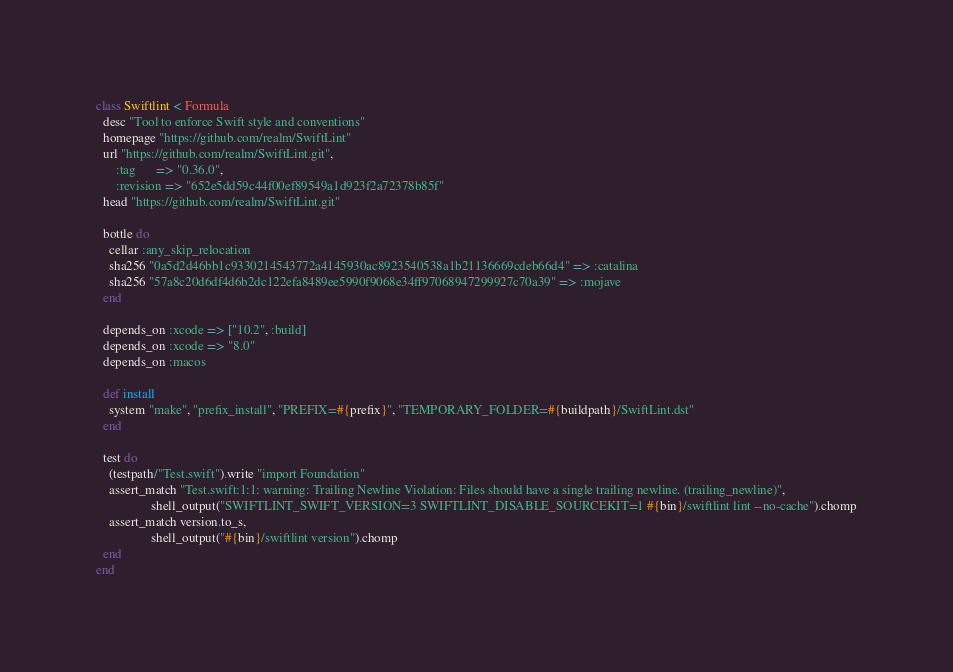<code> <loc_0><loc_0><loc_500><loc_500><_Ruby_>class Swiftlint < Formula
  desc "Tool to enforce Swift style and conventions"
  homepage "https://github.com/realm/SwiftLint"
  url "https://github.com/realm/SwiftLint.git",
      :tag      => "0.36.0",
      :revision => "652e5dd59c44f00ef89549a1d923f2a72378b85f"
  head "https://github.com/realm/SwiftLint.git"

  bottle do
    cellar :any_skip_relocation
    sha256 "0a5d2d46bb1c9330214543772a4145930ac8923540538a1b21136669cdeb66d4" => :catalina
    sha256 "57a8c20d6df4d6b2dc122efa8489ee5990f9068e34ff97068947299927c70a39" => :mojave
  end

  depends_on :xcode => ["10.2", :build]
  depends_on :xcode => "8.0"
  depends_on :macos

  def install
    system "make", "prefix_install", "PREFIX=#{prefix}", "TEMPORARY_FOLDER=#{buildpath}/SwiftLint.dst"
  end

  test do
    (testpath/"Test.swift").write "import Foundation"
    assert_match "Test.swift:1:1: warning: Trailing Newline Violation: Files should have a single trailing newline. (trailing_newline)",
                 shell_output("SWIFTLINT_SWIFT_VERSION=3 SWIFTLINT_DISABLE_SOURCEKIT=1 #{bin}/swiftlint lint --no-cache").chomp
    assert_match version.to_s,
                 shell_output("#{bin}/swiftlint version").chomp
  end
end
</code> 